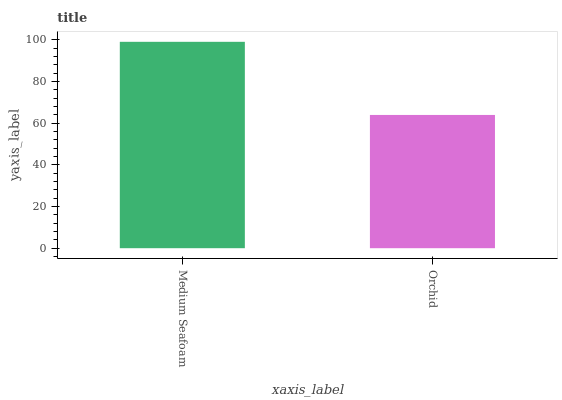Is Orchid the minimum?
Answer yes or no. Yes. Is Medium Seafoam the maximum?
Answer yes or no. Yes. Is Orchid the maximum?
Answer yes or no. No. Is Medium Seafoam greater than Orchid?
Answer yes or no. Yes. Is Orchid less than Medium Seafoam?
Answer yes or no. Yes. Is Orchid greater than Medium Seafoam?
Answer yes or no. No. Is Medium Seafoam less than Orchid?
Answer yes or no. No. Is Medium Seafoam the high median?
Answer yes or no. Yes. Is Orchid the low median?
Answer yes or no. Yes. Is Orchid the high median?
Answer yes or no. No. Is Medium Seafoam the low median?
Answer yes or no. No. 